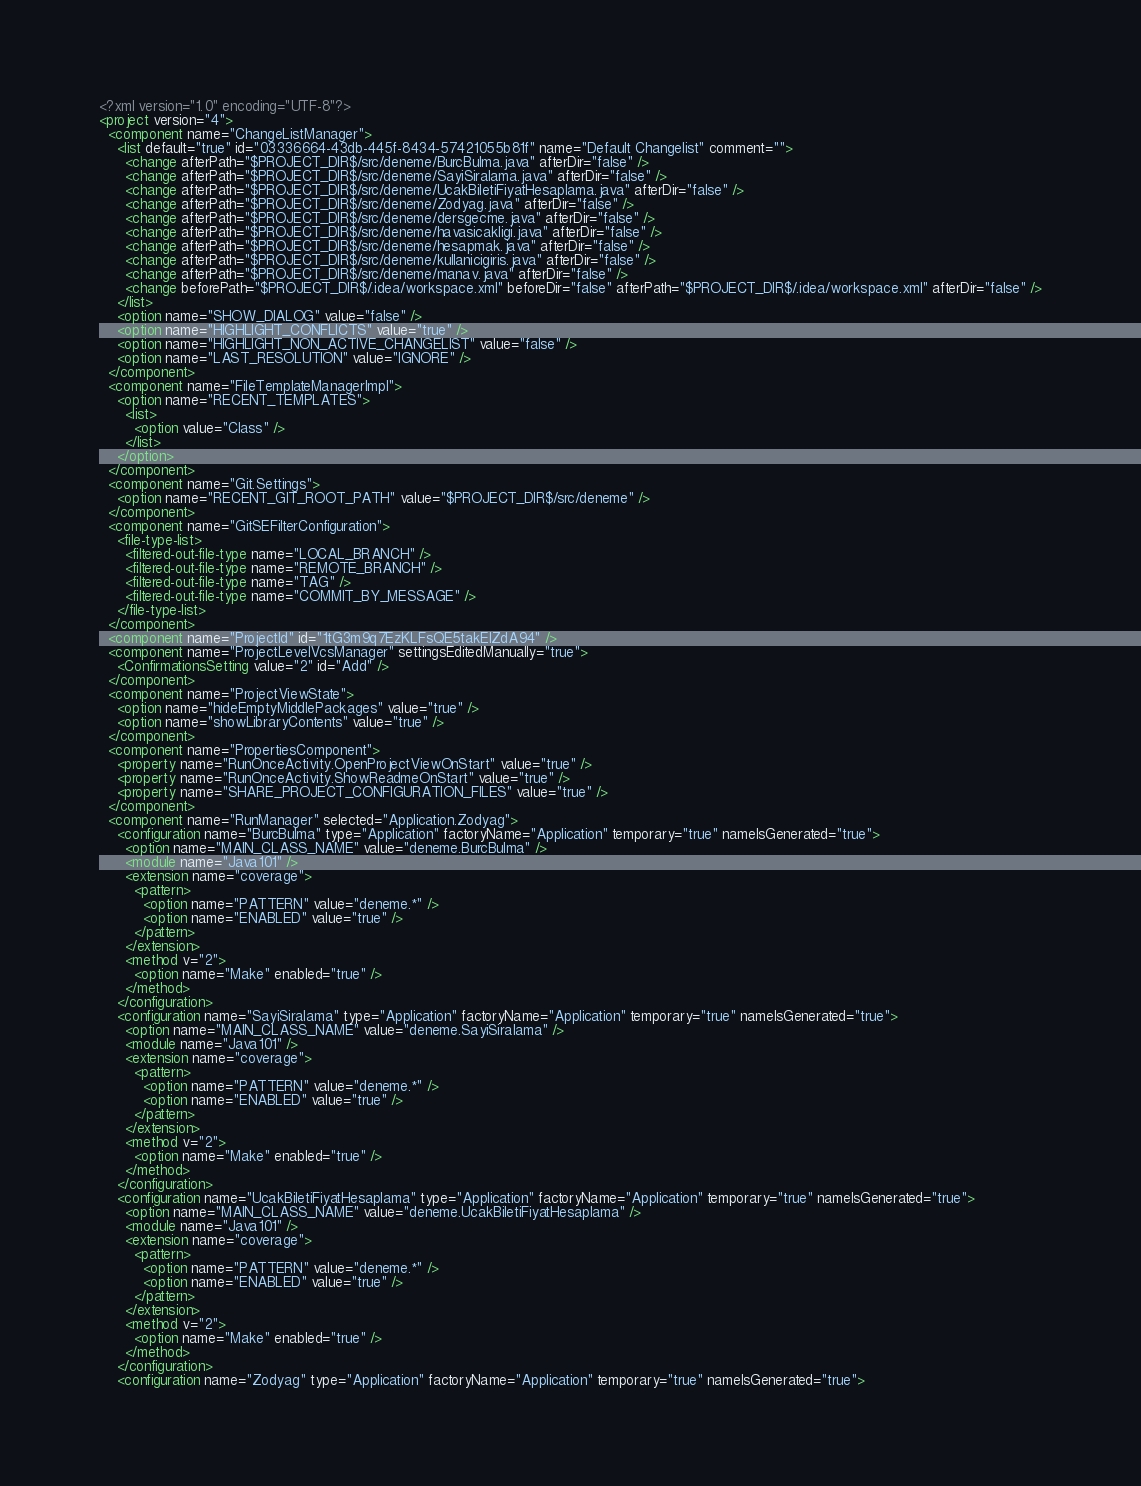Convert code to text. <code><loc_0><loc_0><loc_500><loc_500><_XML_><?xml version="1.0" encoding="UTF-8"?>
<project version="4">
  <component name="ChangeListManager">
    <list default="true" id="03336664-43db-445f-8434-57421055b81f" name="Default Changelist" comment="">
      <change afterPath="$PROJECT_DIR$/src/deneme/BurcBulma.java" afterDir="false" />
      <change afterPath="$PROJECT_DIR$/src/deneme/SayiSiralama.java" afterDir="false" />
      <change afterPath="$PROJECT_DIR$/src/deneme/UcakBiletiFiyatHesaplama.java" afterDir="false" />
      <change afterPath="$PROJECT_DIR$/src/deneme/Zodyag.java" afterDir="false" />
      <change afterPath="$PROJECT_DIR$/src/deneme/dersgecme.java" afterDir="false" />
      <change afterPath="$PROJECT_DIR$/src/deneme/havasicakligi.java" afterDir="false" />
      <change afterPath="$PROJECT_DIR$/src/deneme/hesapmak.java" afterDir="false" />
      <change afterPath="$PROJECT_DIR$/src/deneme/kullanicigiris.java" afterDir="false" />
      <change afterPath="$PROJECT_DIR$/src/deneme/manav.java" afterDir="false" />
      <change beforePath="$PROJECT_DIR$/.idea/workspace.xml" beforeDir="false" afterPath="$PROJECT_DIR$/.idea/workspace.xml" afterDir="false" />
    </list>
    <option name="SHOW_DIALOG" value="false" />
    <option name="HIGHLIGHT_CONFLICTS" value="true" />
    <option name="HIGHLIGHT_NON_ACTIVE_CHANGELIST" value="false" />
    <option name="LAST_RESOLUTION" value="IGNORE" />
  </component>
  <component name="FileTemplateManagerImpl">
    <option name="RECENT_TEMPLATES">
      <list>
        <option value="Class" />
      </list>
    </option>
  </component>
  <component name="Git.Settings">
    <option name="RECENT_GIT_ROOT_PATH" value="$PROJECT_DIR$/src/deneme" />
  </component>
  <component name="GitSEFilterConfiguration">
    <file-type-list>
      <filtered-out-file-type name="LOCAL_BRANCH" />
      <filtered-out-file-type name="REMOTE_BRANCH" />
      <filtered-out-file-type name="TAG" />
      <filtered-out-file-type name="COMMIT_BY_MESSAGE" />
    </file-type-list>
  </component>
  <component name="ProjectId" id="1tG3m9q7EzKLFsQE5takEIZdA94" />
  <component name="ProjectLevelVcsManager" settingsEditedManually="true">
    <ConfirmationsSetting value="2" id="Add" />
  </component>
  <component name="ProjectViewState">
    <option name="hideEmptyMiddlePackages" value="true" />
    <option name="showLibraryContents" value="true" />
  </component>
  <component name="PropertiesComponent">
    <property name="RunOnceActivity.OpenProjectViewOnStart" value="true" />
    <property name="RunOnceActivity.ShowReadmeOnStart" value="true" />
    <property name="SHARE_PROJECT_CONFIGURATION_FILES" value="true" />
  </component>
  <component name="RunManager" selected="Application.Zodyag">
    <configuration name="BurcBulma" type="Application" factoryName="Application" temporary="true" nameIsGenerated="true">
      <option name="MAIN_CLASS_NAME" value="deneme.BurcBulma" />
      <module name="Java101" />
      <extension name="coverage">
        <pattern>
          <option name="PATTERN" value="deneme.*" />
          <option name="ENABLED" value="true" />
        </pattern>
      </extension>
      <method v="2">
        <option name="Make" enabled="true" />
      </method>
    </configuration>
    <configuration name="SayiSiralama" type="Application" factoryName="Application" temporary="true" nameIsGenerated="true">
      <option name="MAIN_CLASS_NAME" value="deneme.SayiSiralama" />
      <module name="Java101" />
      <extension name="coverage">
        <pattern>
          <option name="PATTERN" value="deneme.*" />
          <option name="ENABLED" value="true" />
        </pattern>
      </extension>
      <method v="2">
        <option name="Make" enabled="true" />
      </method>
    </configuration>
    <configuration name="UcakBiletiFiyatHesaplama" type="Application" factoryName="Application" temporary="true" nameIsGenerated="true">
      <option name="MAIN_CLASS_NAME" value="deneme.UcakBiletiFiyatHesaplama" />
      <module name="Java101" />
      <extension name="coverage">
        <pattern>
          <option name="PATTERN" value="deneme.*" />
          <option name="ENABLED" value="true" />
        </pattern>
      </extension>
      <method v="2">
        <option name="Make" enabled="true" />
      </method>
    </configuration>
    <configuration name="Zodyag" type="Application" factoryName="Application" temporary="true" nameIsGenerated="true"></code> 